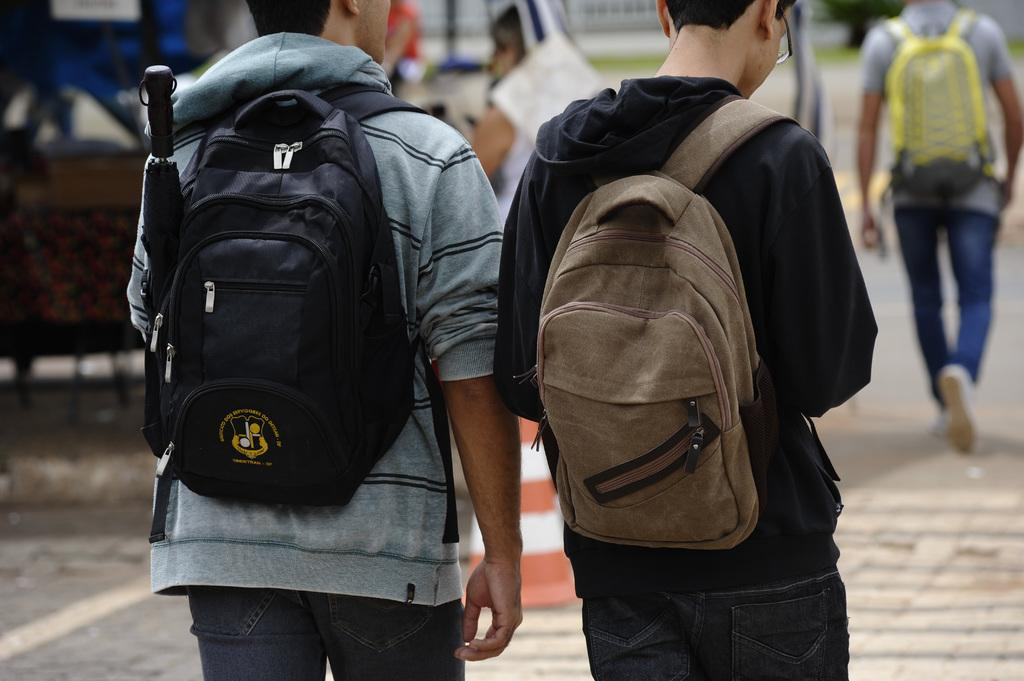How many people are in the image? There are two men in the image. What are the men wearing on their backs? The men are wearing backpacks. Where are the backpacks positioned on their bodies? The backpacks are on their backs. Can you describe the person walking in the image? There is a person walking on the sidewalk. What type of bulb is hanging from the leg of the person walking in the image? There is no bulb present in the image, nor is there any indication of a leg hanging from the person walking. 